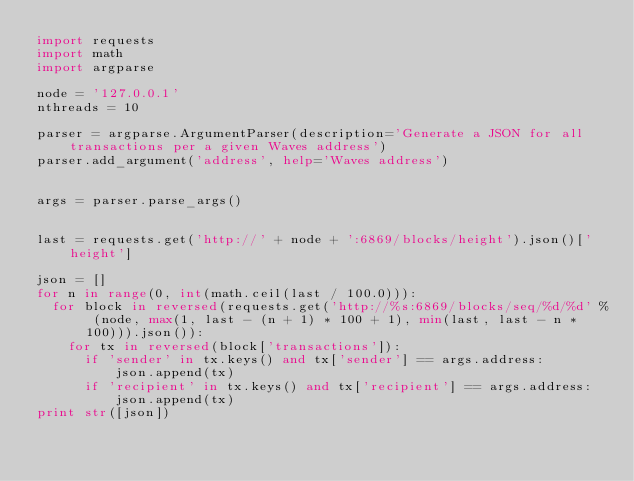<code> <loc_0><loc_0><loc_500><loc_500><_Python_>import requests
import math
import argparse

node = '127.0.0.1'
nthreads = 10

parser = argparse.ArgumentParser(description='Generate a JSON for all transactions per a given Waves address')
parser.add_argument('address', help='Waves address')


args = parser.parse_args()


last = requests.get('http://' + node + ':6869/blocks/height').json()['height']

json = []
for n in range(0, int(math.ceil(last / 100.0))):
	for block in reversed(requests.get('http://%s:6869/blocks/seq/%d/%d' % (node, max(1, last - (n + 1) * 100 + 1), min(last, last - n * 100))).json()):
		for tx in reversed(block['transactions']):
			if 'sender' in tx.keys() and tx['sender'] == args.address:
					json.append(tx)
			if 'recipient' in tx.keys() and tx['recipient'] == args.address:
					json.append(tx)
print str([json])

</code> 